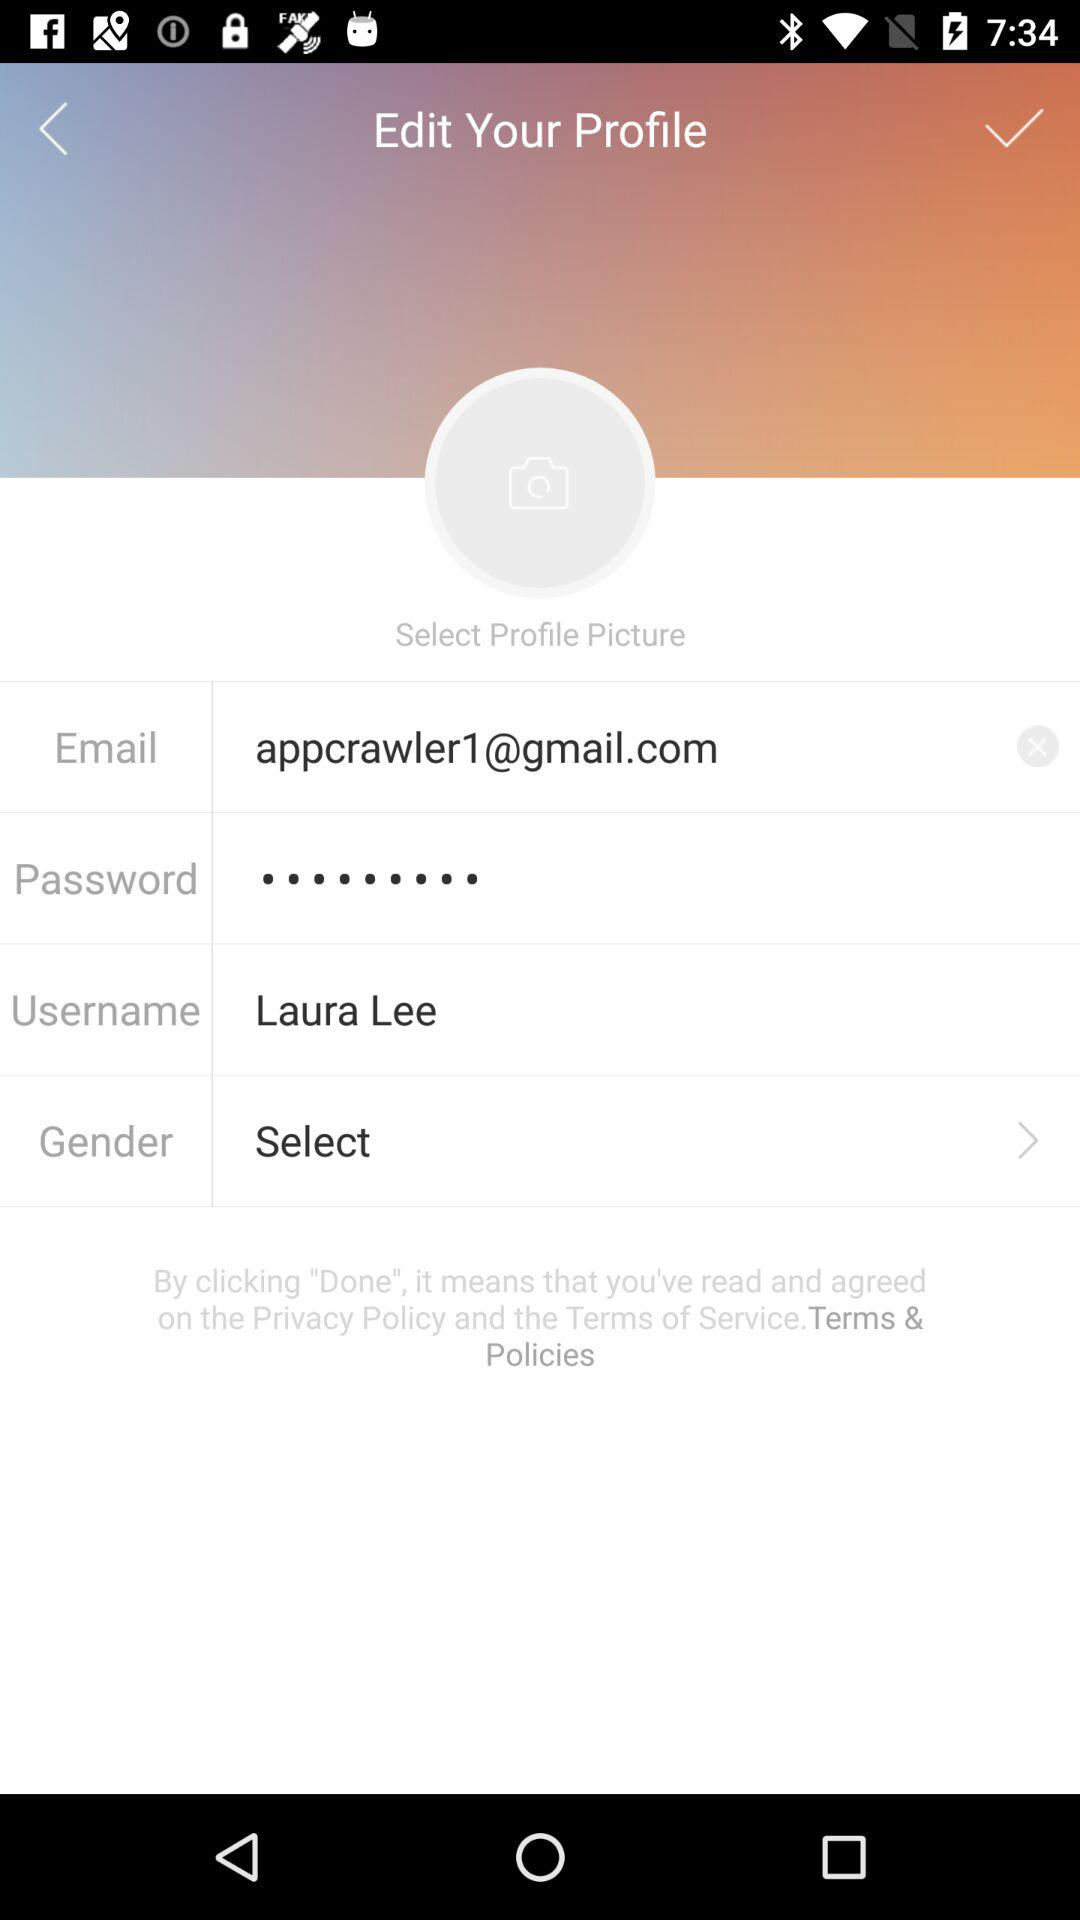How many profile details are there?
Answer the question using a single word or phrase. 4 